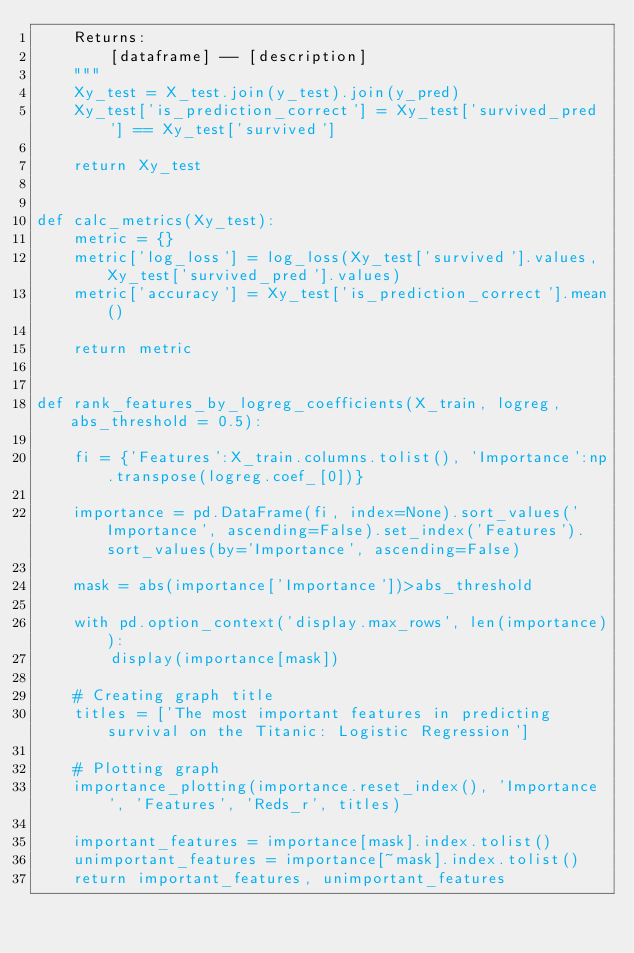Convert code to text. <code><loc_0><loc_0><loc_500><loc_500><_Python_>    Returns:
        [dataframe] -- [description]
    """
    Xy_test = X_test.join(y_test).join(y_pred)
    Xy_test['is_prediction_correct'] = Xy_test['survived_pred'] == Xy_test['survived']
    
    return Xy_test


def calc_metrics(Xy_test):
    metric = {}
    metric['log_loss'] = log_loss(Xy_test['survived'].values, Xy_test['survived_pred'].values)
    metric['accuracy'] = Xy_test['is_prediction_correct'].mean()
    
    return metric


def rank_features_by_logreg_coefficients(X_train, logreg, abs_threshold = 0.5):
    
    fi = {'Features':X_train.columns.tolist(), 'Importance':np.transpose(logreg.coef_[0])}

    importance = pd.DataFrame(fi, index=None).sort_values('Importance', ascending=False).set_index('Features').sort_values(by='Importance', ascending=False)

    mask = abs(importance['Importance'])>abs_threshold

    with pd.option_context('display.max_rows', len(importance)):
        display(importance[mask])
    
    # Creating graph title
    titles = ['The most important features in predicting survival on the Titanic: Logistic Regression']

    # Plotting graph
    importance_plotting(importance.reset_index(), 'Importance', 'Features', 'Reds_r', titles)
    
    important_features = importance[mask].index.tolist()
    unimportant_features = importance[~mask].index.tolist()
    return important_features, unimportant_features

    </code> 